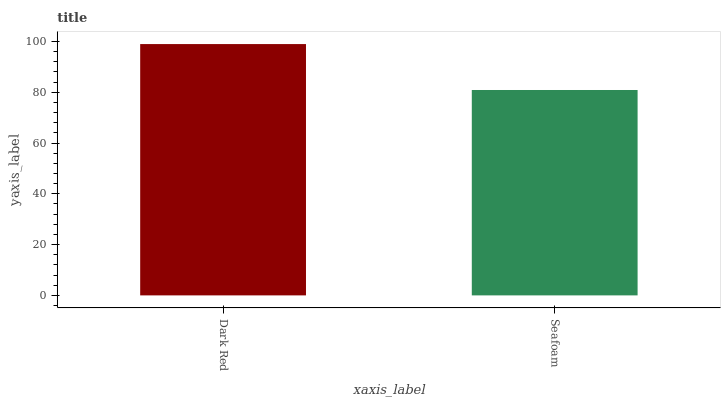Is Seafoam the minimum?
Answer yes or no. Yes. Is Dark Red the maximum?
Answer yes or no. Yes. Is Seafoam the maximum?
Answer yes or no. No. Is Dark Red greater than Seafoam?
Answer yes or no. Yes. Is Seafoam less than Dark Red?
Answer yes or no. Yes. Is Seafoam greater than Dark Red?
Answer yes or no. No. Is Dark Red less than Seafoam?
Answer yes or no. No. Is Dark Red the high median?
Answer yes or no. Yes. Is Seafoam the low median?
Answer yes or no. Yes. Is Seafoam the high median?
Answer yes or no. No. Is Dark Red the low median?
Answer yes or no. No. 